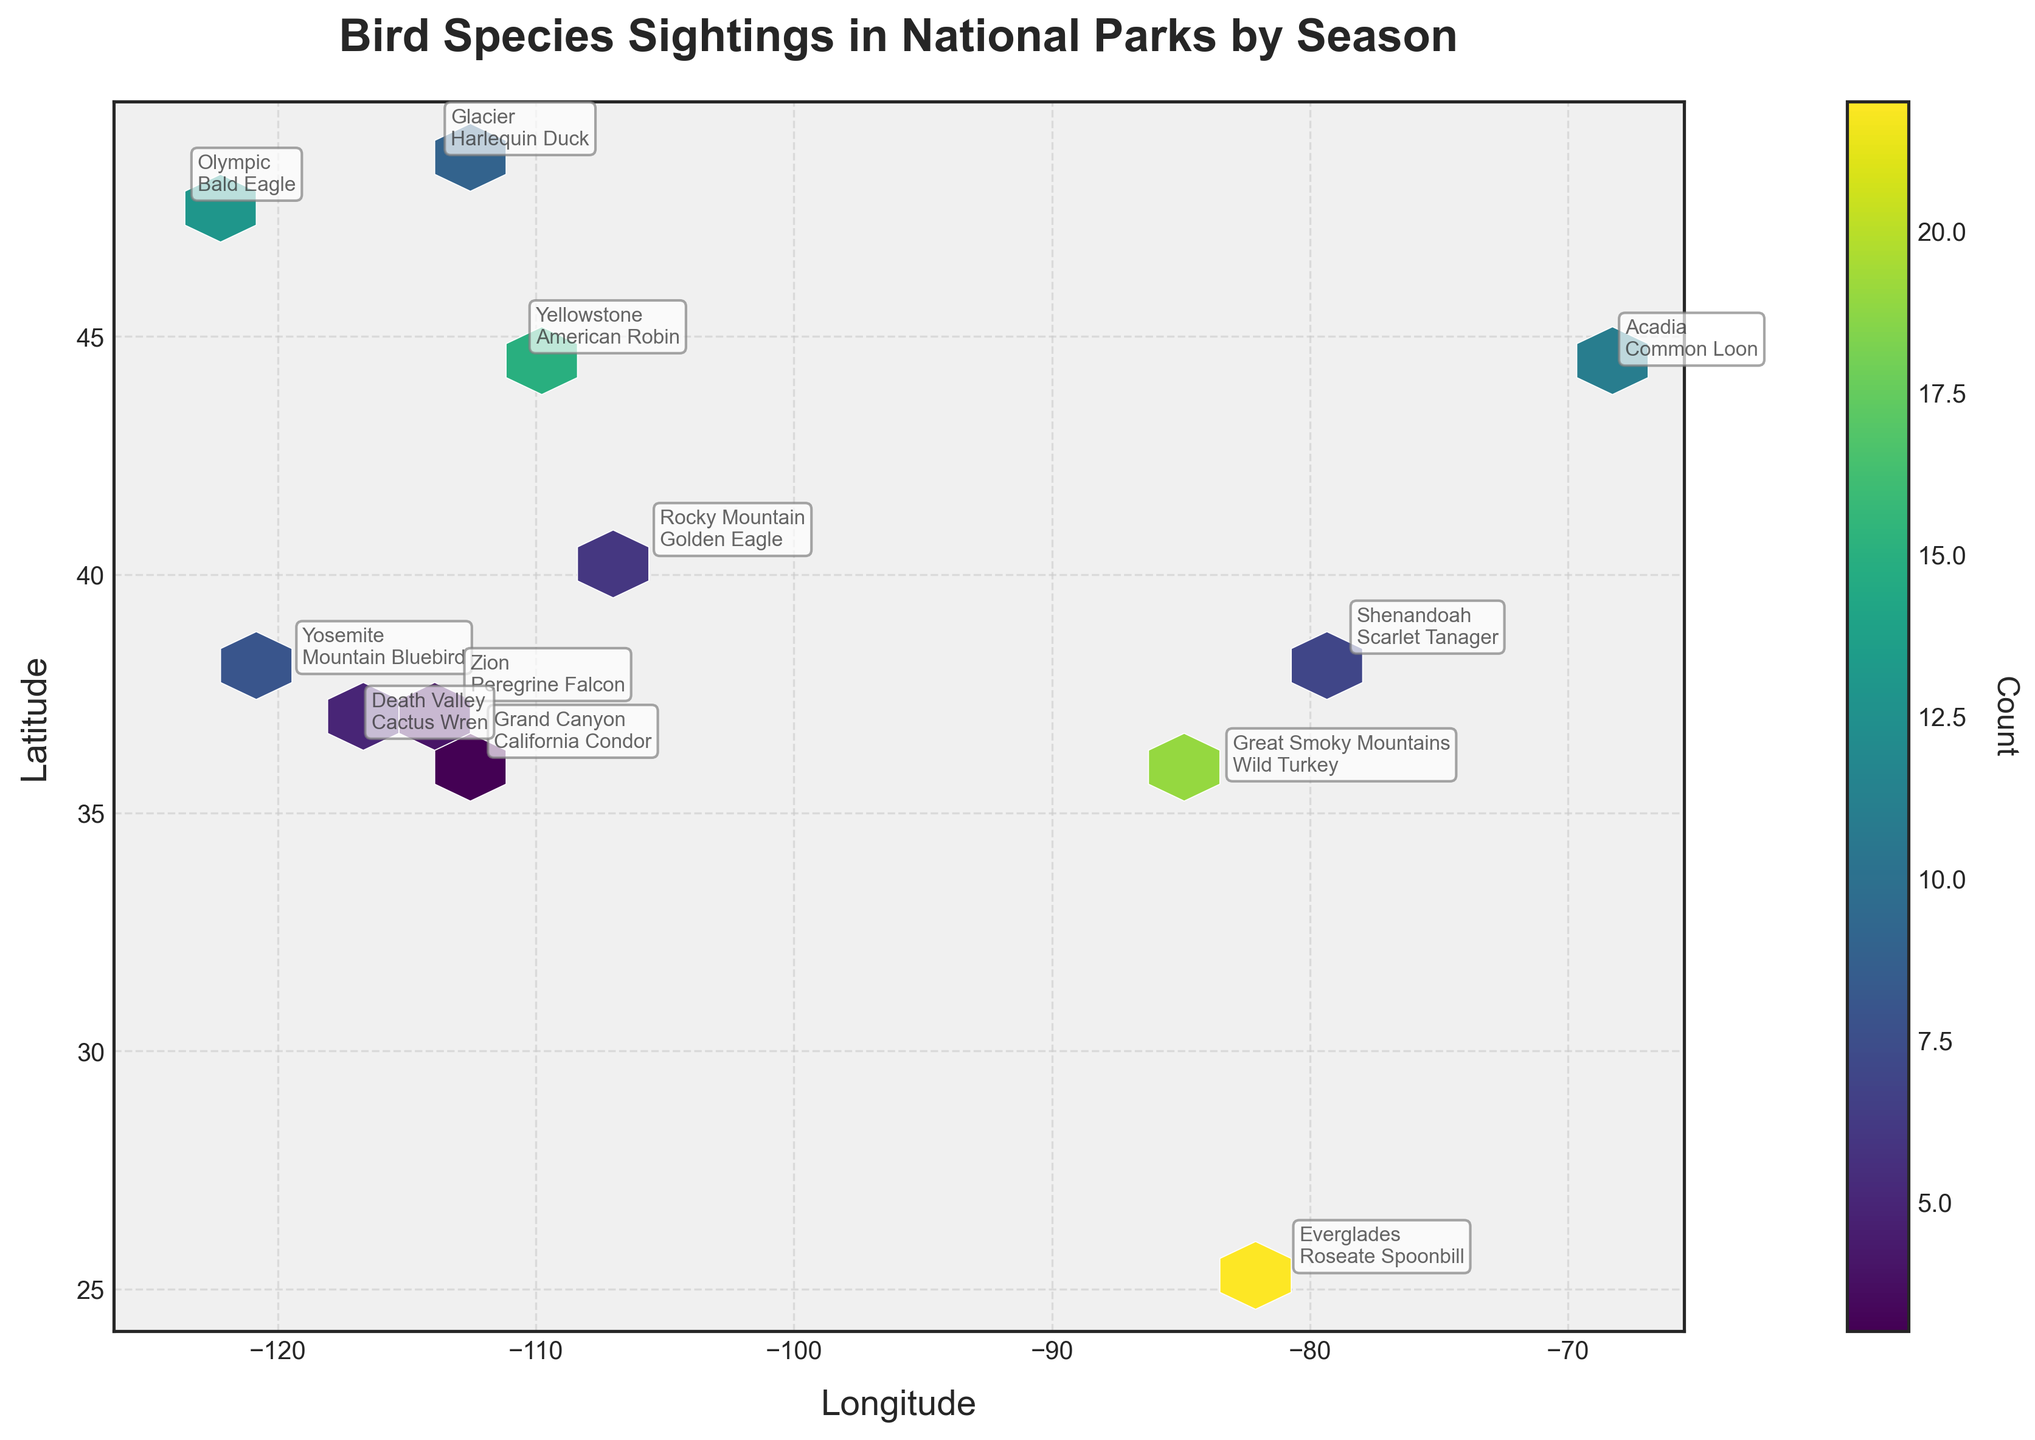What's the title of the figure? The title of the figure is displayed on top and it summarizes the main topic presented in the plot.
Answer: Bird Species Sightings in National Parks by Season Which axis represents the latitude? The y-axis is labeled with "Latitude," indicating that it represents the latitude values.
Answer: y-axis How many parks are annotated in the Spring season? We need to count the annotations labeled with the "Spring" season on the plot, e.g., Yellowstone, Yosemite, and Glacier.
Answer: 3 Which national park has the highest recorded bird sighting count? By checking the hexbin colors and annotations, we find the park with the highest count, which is Everglades with 22 sightings.
Answer: Everglades What is the range of longitude values in this plot? We look at the x-axis ticks to get the minimum and maximum longitude values shown on the plot, which range roughly from -117 to -68.
Answer: -117 to -68 Which bird species is sighted in the Grand Canyon during the Summer? We look at the annotations and find the sighting in the Grand Canyon during Summer: the California Condor.
Answer: California Condor Compare the bird sightings in Winter and Summer. Which has more instances? We evaluate the counts in the Winter season (Golden Eagle 6 + Bald Eagle 13 + Cactus Wren 5 = 24) and the Summer season (California Condor 3 + Roseate Spoonbill 22 + Peregrine Falcon 4 = 29).
Answer: Summer In which national park is the Scarlet Tanager sighted, and which season? From the annotations, we see that the Scarlet Tanager is sighted in Shenandoah during the Fall.
Answer: Shenandoah, Fall What's the sum of bird sightings in Acadia and Great Smoky Mountains during the Fall? We add up the counts for Acadia (Common Loon 11) and Great Smoky Mountains (Wild Turkey 19), resulting in 11 + 19 = 30.
Answer: 30 What is the average bird sighting count for the seasons represented in the plot? Summing all counts (15 + 8 + 3 + 22 + 11 + 19 + 6 + 13 + 9 + 4 + 7 + 5 = 122) and dividing by the number of sightings (12), we get an average: 122 / 12 ≈ 10.17.
Answer: 10.17 